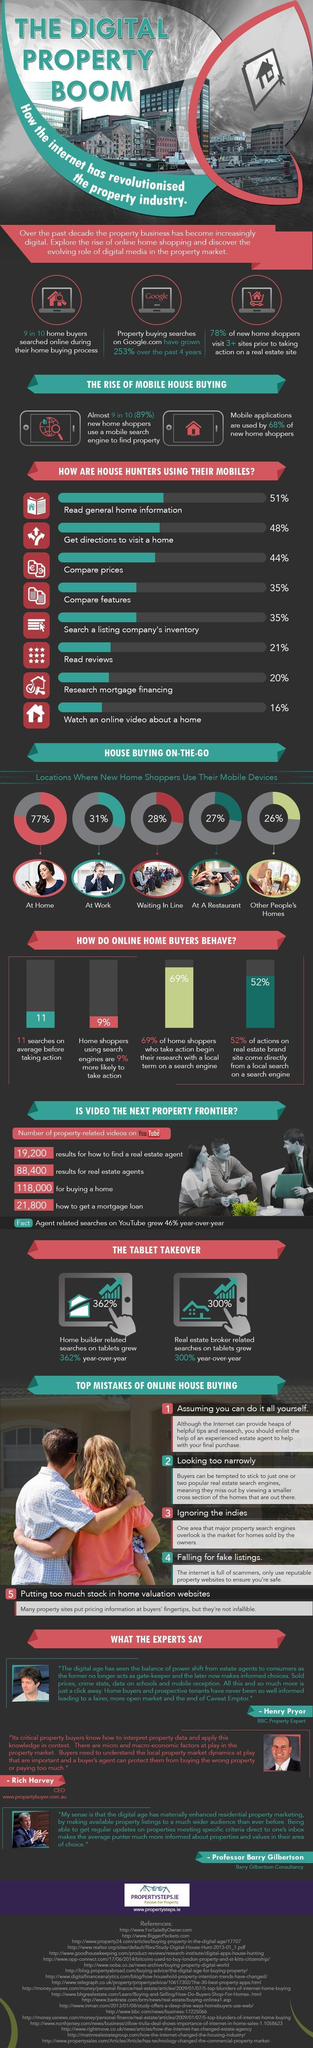how many of the home shoppers searched online during their home buying process?
Answer the question with a short phrase. 9 in 10 What percent of home buyers read reviews on their mobiles? 21% What percent of new home buyers visit minimum 3 sites before taking action? 78% Where do majority of home buyers use their mobile devices? at home By what percent did home builder related search on tablets grow? 362% what was used by 68% of new home shoppers? mobile applications What percent of home shopper use their mobile devices at home? 77% What went up by 253% over the past 4 years? Property buying searches on Google.com Where do 31% of new home buyers use their mobile devices from? at work 